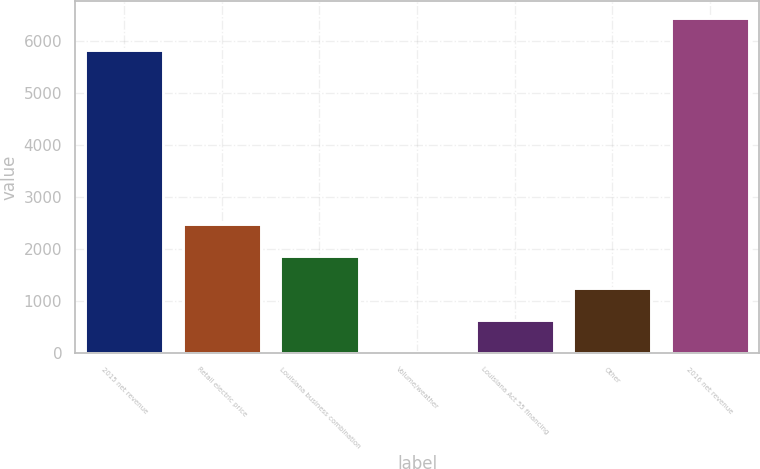Convert chart. <chart><loc_0><loc_0><loc_500><loc_500><bar_chart><fcel>2015 net revenue<fcel>Retail electric price<fcel>Louisiana business combination<fcel>Volume/weather<fcel>Louisiana Act 55 financing<fcel>Other<fcel>2016 net revenue<nl><fcel>5829<fcel>2480<fcel>1863.5<fcel>14<fcel>630.5<fcel>1247<fcel>6445.5<nl></chart> 